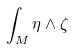<formula> <loc_0><loc_0><loc_500><loc_500>\int _ { M } \eta \wedge \zeta</formula> 